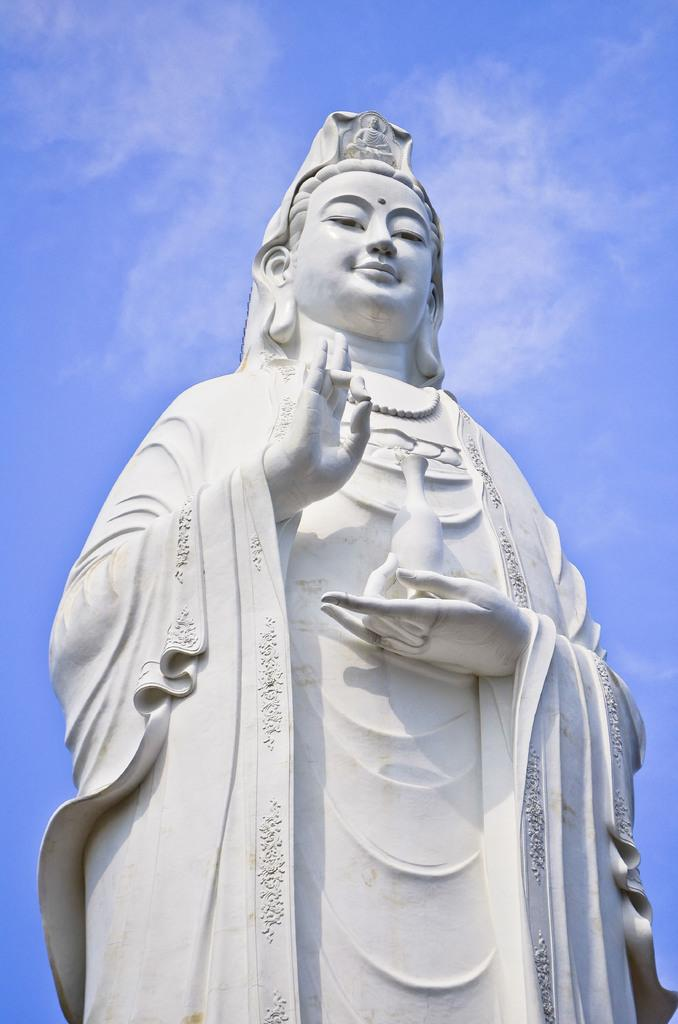What is the main subject in the image? There is a statue in the image. What can be seen in the background of the image? The sky is visible in the background of the image. How many lizards are crawling on the statue in the image? There are no lizards present on the statue in the image. What type of metal is the statue made of in the image? The facts provided do not mention the type of metal the statue is made of, so it cannot be determined from the image. 